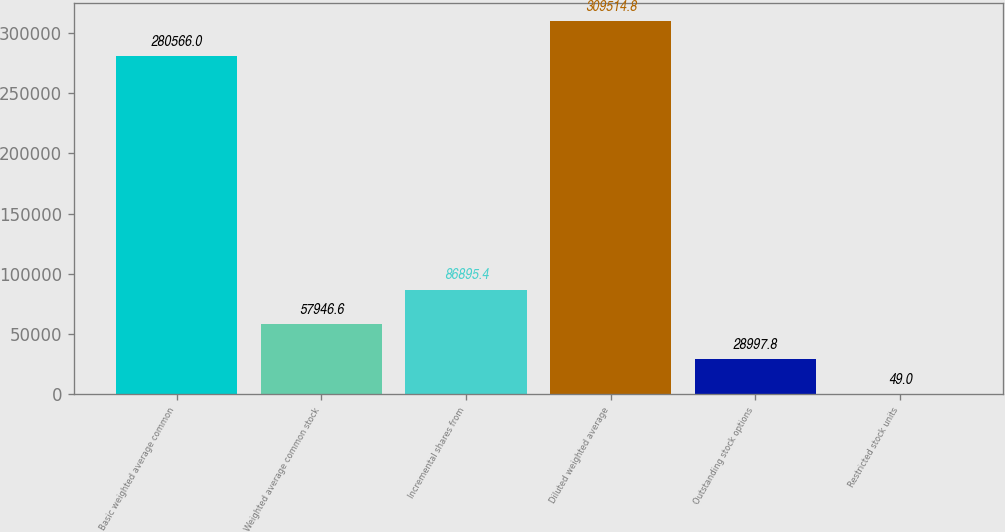<chart> <loc_0><loc_0><loc_500><loc_500><bar_chart><fcel>Basic weighted average common<fcel>Weighted average common stock<fcel>Incremental shares from<fcel>Diluted weighted average<fcel>Outstanding stock options<fcel>Restricted stock units<nl><fcel>280566<fcel>57946.6<fcel>86895.4<fcel>309515<fcel>28997.8<fcel>49<nl></chart> 